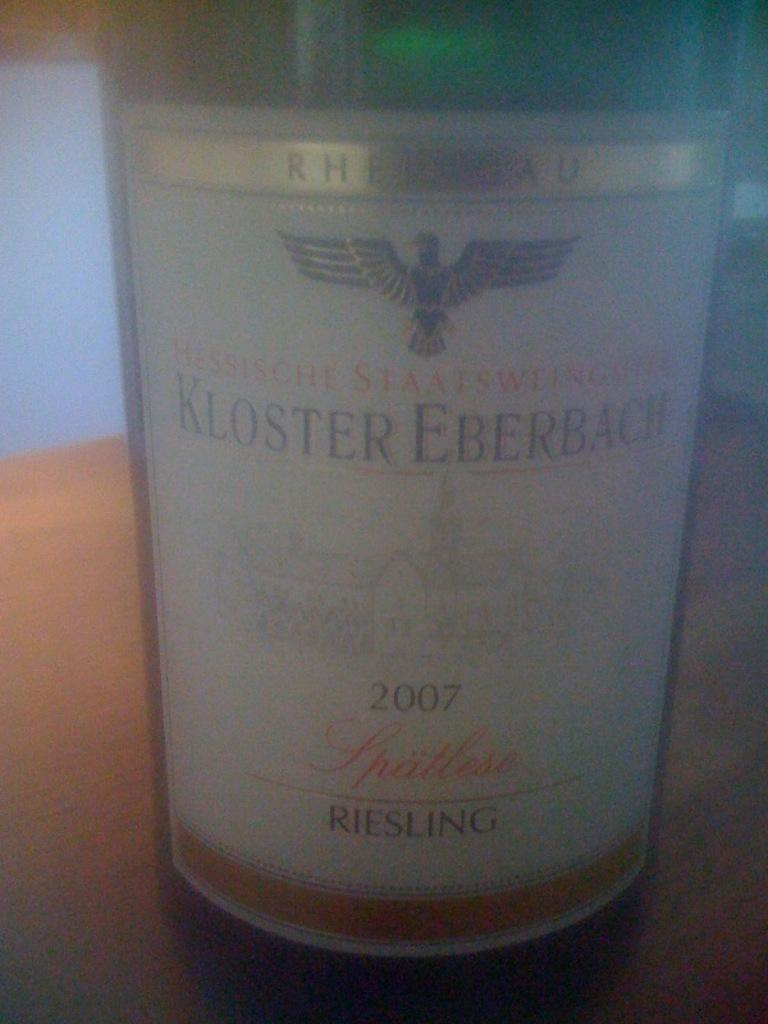Provide a one-sentence caption for the provided image. Bottle of Kloster Eberbach 2007 Riesling bottle up close picture. 